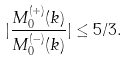Convert formula to latex. <formula><loc_0><loc_0><loc_500><loc_500>| \frac { M _ { 0 } ^ { ( + ) } ( k ) } { M _ { 0 } ^ { ( - ) } ( k ) } | \leq 5 / 3 .</formula> 